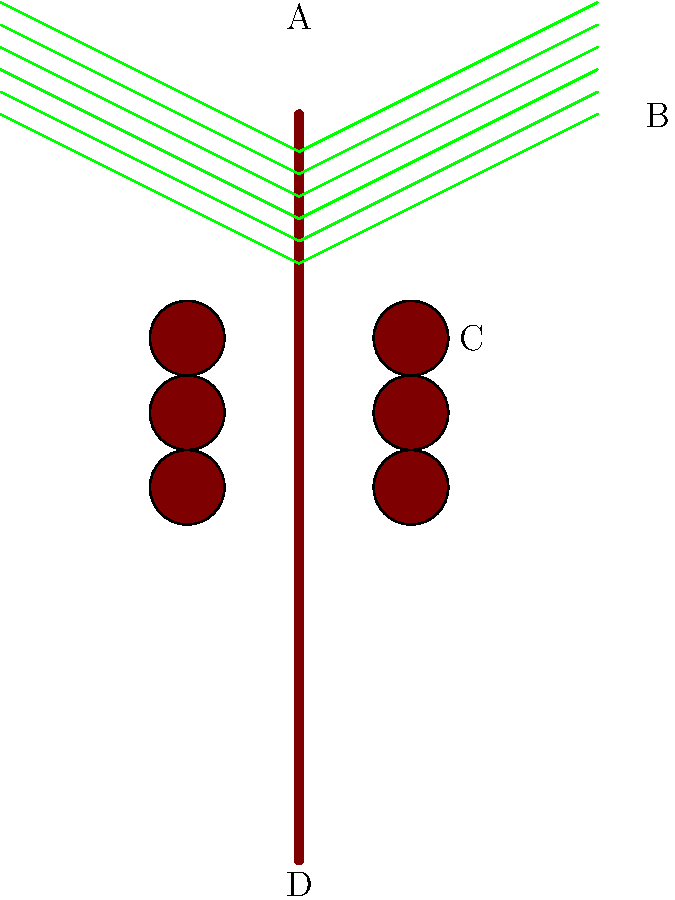In this illustration of a date palm tree, which part is labeled "C"? Let's go through the parts of the date palm tree in this illustration:

1. The vertical brown line represents the trunk of the tree, which extends from the bottom to the top of the image. This is labeled "D" at the base.

2. At the top of the trunk, we see green lines extending outwards. These represent the leaves or fronds of the date palm. They are labeled "B" at the tip.

3. The topmost part of the tree, where the leaves originate, is labeled "A". This area is called the crown or the top of the palm.

4. In the middle section of the trunk, we see round brown objects. These represent the date clusters, which are the fruit of the date palm. These are labeled "C".

Therefore, the part labeled "C" in this illustration represents the dates or date clusters of the palm tree.
Answer: Dates (or date clusters) 